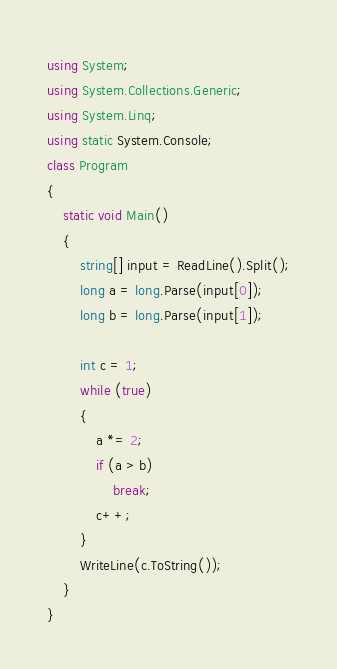<code> <loc_0><loc_0><loc_500><loc_500><_C#_>using System;
using System.Collections.Generic;
using System.Linq;
using static System.Console;
class Program
{
    static void Main()
    {
        string[] input = ReadLine().Split();
        long a = long.Parse(input[0]);
        long b = long.Parse(input[1]);

        int c = 1;
        while (true)
        {
            a *= 2;
            if (a > b)
                break;
            c++;
        }
        WriteLine(c.ToString());
    }
}</code> 